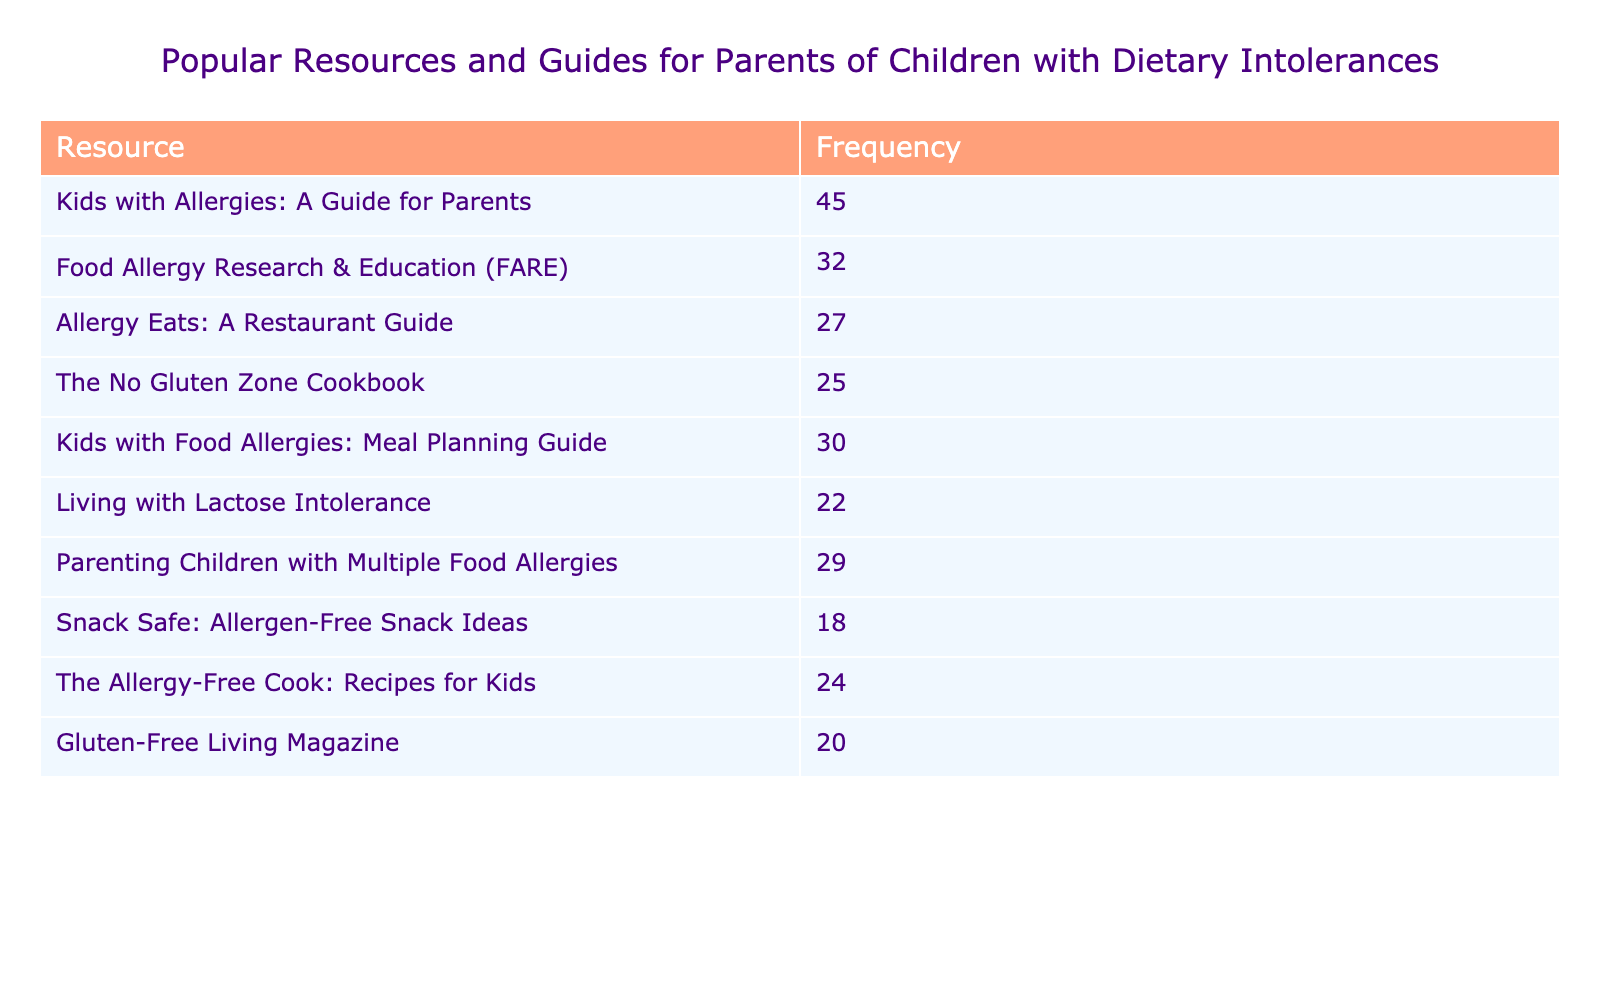What is the most popular resource among parents of children with dietary intolerances? The table lists resources along with their frequencies. Looking at the 'Frequency' column, "Kids with Allergies: A Guide for Parents" has the highest frequency at 45.
Answer: 45 How many resources have a frequency of 30 or above? I will count the resources that have a frequency of 30 or above: "Kids with Allergies: A Guide for Parents" (45), "Kids with Food Allergies: Meal Planning Guide" (30), and "Food Allergy Research & Education (FARE)" (32), totaling three.
Answer: 3 What is the frequency of "Living with Lactose Intolerance"? By scanning the table, "Living with Lactose Intolerance" shows a frequency of 22.
Answer: 22 Are there more resources with a frequency less than 20 than those with a frequency of 25 or more? I need to count the resources with frequency less than 20: "Snack Safe: Allergen-Free Snack Ideas" (18) and none others, giving a total of 1. Now count those with frequency of 25 or more: "Kids with Allergies: A Guide for Parents" (45), "Food Allergy Research & Education (FARE)" (32), "Kids with Food Allergies: Meal Planning Guide" (30), "Allergy Eats: A Restaurant Guide" (27), "The No Gluten Zone Cookbook" (25), totaling 5. Comparing, there are more resources with a frequency of 25 or more.
Answer: No What is the total frequency of all resources listed in the table? I will sum up all the frequencies listed: 45 + 32 + 27 + 25 + 30 + 22 + 29 + 18 + 24 + 20 =  252.
Answer: 252 Which resource has the lowest frequency, and what is that frequency? In the frequency column, "Snack Safe: Allergen-Free Snack Ideas" has the lowest frequency, which is 18.
Answer: 18 What is the average frequency of the resources listed in the table? There are 10 resources. To find the average, sum the frequencies (252) and divide by the number of resources (10). So, 252/10 = 25.2.
Answer: 25.2 Is "The Allergy-Free Cook: Recipes for Kids" more popular than "Gluten-Free Living Magazine"? I will compare their frequencies: "The Allergy-Free Cook: Recipes for Kids" has a frequency of 24, while "Gluten-Free Living Magazine" has a frequency of 20. Since 24 is greater than 20, it confirms that it is indeed more popular.
Answer: Yes Which resource has a frequency closest to the average frequency? The average frequency is 25.2. Looking at the frequencies, "The Allergy-Free Cook: Recipes for Kids" (24) is closest to the average.
Answer: 24 